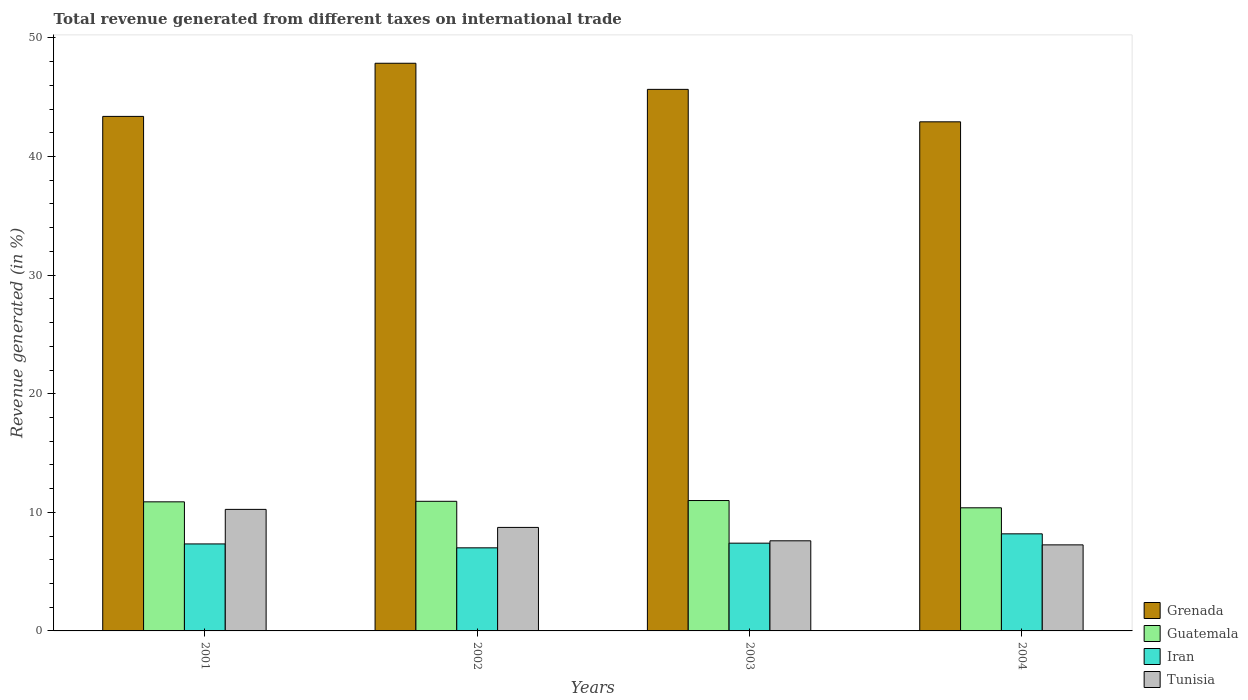How many groups of bars are there?
Offer a very short reply. 4. Are the number of bars per tick equal to the number of legend labels?
Make the answer very short. Yes. What is the total revenue generated in Iran in 2004?
Your answer should be very brief. 8.19. Across all years, what is the maximum total revenue generated in Iran?
Your answer should be very brief. 8.19. Across all years, what is the minimum total revenue generated in Grenada?
Ensure brevity in your answer.  42.93. In which year was the total revenue generated in Tunisia maximum?
Offer a very short reply. 2001. What is the total total revenue generated in Guatemala in the graph?
Provide a succinct answer. 43.19. What is the difference between the total revenue generated in Guatemala in 2002 and that in 2004?
Offer a terse response. 0.55. What is the difference between the total revenue generated in Iran in 2003 and the total revenue generated in Grenada in 2004?
Provide a short and direct response. -35.53. What is the average total revenue generated in Tunisia per year?
Ensure brevity in your answer.  8.46. In the year 2003, what is the difference between the total revenue generated in Iran and total revenue generated in Grenada?
Ensure brevity in your answer.  -38.26. What is the ratio of the total revenue generated in Iran in 2001 to that in 2004?
Offer a very short reply. 0.9. Is the total revenue generated in Guatemala in 2001 less than that in 2002?
Offer a terse response. Yes. What is the difference between the highest and the second highest total revenue generated in Grenada?
Offer a terse response. 2.2. What is the difference between the highest and the lowest total revenue generated in Tunisia?
Offer a terse response. 2.99. What does the 2nd bar from the left in 2004 represents?
Keep it short and to the point. Guatemala. What does the 3rd bar from the right in 2004 represents?
Ensure brevity in your answer.  Guatemala. Is it the case that in every year, the sum of the total revenue generated in Tunisia and total revenue generated in Grenada is greater than the total revenue generated in Guatemala?
Ensure brevity in your answer.  Yes. Are all the bars in the graph horizontal?
Provide a succinct answer. No. What is the difference between two consecutive major ticks on the Y-axis?
Your answer should be compact. 10. Where does the legend appear in the graph?
Offer a terse response. Bottom right. How many legend labels are there?
Your answer should be very brief. 4. What is the title of the graph?
Your response must be concise. Total revenue generated from different taxes on international trade. Does "Guam" appear as one of the legend labels in the graph?
Make the answer very short. No. What is the label or title of the Y-axis?
Your answer should be compact. Revenue generated (in %). What is the Revenue generated (in %) of Grenada in 2001?
Provide a short and direct response. 43.38. What is the Revenue generated (in %) of Guatemala in 2001?
Ensure brevity in your answer.  10.88. What is the Revenue generated (in %) of Iran in 2001?
Your response must be concise. 7.34. What is the Revenue generated (in %) in Tunisia in 2001?
Ensure brevity in your answer.  10.25. What is the Revenue generated (in %) of Grenada in 2002?
Your answer should be very brief. 47.86. What is the Revenue generated (in %) of Guatemala in 2002?
Give a very brief answer. 10.93. What is the Revenue generated (in %) of Iran in 2002?
Keep it short and to the point. 7.01. What is the Revenue generated (in %) of Tunisia in 2002?
Offer a very short reply. 8.73. What is the Revenue generated (in %) of Grenada in 2003?
Provide a short and direct response. 45.66. What is the Revenue generated (in %) of Guatemala in 2003?
Your answer should be compact. 10.99. What is the Revenue generated (in %) in Iran in 2003?
Keep it short and to the point. 7.4. What is the Revenue generated (in %) in Tunisia in 2003?
Your answer should be very brief. 7.6. What is the Revenue generated (in %) of Grenada in 2004?
Provide a succinct answer. 42.93. What is the Revenue generated (in %) in Guatemala in 2004?
Offer a very short reply. 10.38. What is the Revenue generated (in %) of Iran in 2004?
Give a very brief answer. 8.19. What is the Revenue generated (in %) of Tunisia in 2004?
Offer a terse response. 7.26. Across all years, what is the maximum Revenue generated (in %) of Grenada?
Give a very brief answer. 47.86. Across all years, what is the maximum Revenue generated (in %) of Guatemala?
Make the answer very short. 10.99. Across all years, what is the maximum Revenue generated (in %) in Iran?
Make the answer very short. 8.19. Across all years, what is the maximum Revenue generated (in %) in Tunisia?
Keep it short and to the point. 10.25. Across all years, what is the minimum Revenue generated (in %) in Grenada?
Provide a short and direct response. 42.93. Across all years, what is the minimum Revenue generated (in %) of Guatemala?
Provide a succinct answer. 10.38. Across all years, what is the minimum Revenue generated (in %) of Iran?
Give a very brief answer. 7.01. Across all years, what is the minimum Revenue generated (in %) in Tunisia?
Provide a succinct answer. 7.26. What is the total Revenue generated (in %) in Grenada in the graph?
Your response must be concise. 179.84. What is the total Revenue generated (in %) of Guatemala in the graph?
Offer a very short reply. 43.19. What is the total Revenue generated (in %) in Iran in the graph?
Offer a very short reply. 29.93. What is the total Revenue generated (in %) in Tunisia in the graph?
Your response must be concise. 33.83. What is the difference between the Revenue generated (in %) of Grenada in 2001 and that in 2002?
Provide a short and direct response. -4.48. What is the difference between the Revenue generated (in %) in Guatemala in 2001 and that in 2002?
Give a very brief answer. -0.05. What is the difference between the Revenue generated (in %) of Iran in 2001 and that in 2002?
Provide a succinct answer. 0.33. What is the difference between the Revenue generated (in %) of Tunisia in 2001 and that in 2002?
Offer a very short reply. 1.52. What is the difference between the Revenue generated (in %) in Grenada in 2001 and that in 2003?
Offer a terse response. -2.28. What is the difference between the Revenue generated (in %) in Guatemala in 2001 and that in 2003?
Ensure brevity in your answer.  -0.11. What is the difference between the Revenue generated (in %) of Iran in 2001 and that in 2003?
Your answer should be very brief. -0.06. What is the difference between the Revenue generated (in %) of Tunisia in 2001 and that in 2003?
Offer a very short reply. 2.65. What is the difference between the Revenue generated (in %) in Grenada in 2001 and that in 2004?
Offer a terse response. 0.46. What is the difference between the Revenue generated (in %) in Guatemala in 2001 and that in 2004?
Give a very brief answer. 0.5. What is the difference between the Revenue generated (in %) of Iran in 2001 and that in 2004?
Make the answer very short. -0.85. What is the difference between the Revenue generated (in %) in Tunisia in 2001 and that in 2004?
Offer a terse response. 2.99. What is the difference between the Revenue generated (in %) of Grenada in 2002 and that in 2003?
Offer a very short reply. 2.2. What is the difference between the Revenue generated (in %) in Guatemala in 2002 and that in 2003?
Keep it short and to the point. -0.06. What is the difference between the Revenue generated (in %) in Iran in 2002 and that in 2003?
Keep it short and to the point. -0.39. What is the difference between the Revenue generated (in %) in Tunisia in 2002 and that in 2003?
Keep it short and to the point. 1.13. What is the difference between the Revenue generated (in %) in Grenada in 2002 and that in 2004?
Give a very brief answer. 4.94. What is the difference between the Revenue generated (in %) in Guatemala in 2002 and that in 2004?
Give a very brief answer. 0.55. What is the difference between the Revenue generated (in %) of Iran in 2002 and that in 2004?
Your answer should be compact. -1.18. What is the difference between the Revenue generated (in %) of Tunisia in 2002 and that in 2004?
Provide a succinct answer. 1.47. What is the difference between the Revenue generated (in %) in Grenada in 2003 and that in 2004?
Offer a terse response. 2.74. What is the difference between the Revenue generated (in %) of Guatemala in 2003 and that in 2004?
Your answer should be compact. 0.61. What is the difference between the Revenue generated (in %) in Iran in 2003 and that in 2004?
Provide a succinct answer. -0.79. What is the difference between the Revenue generated (in %) in Tunisia in 2003 and that in 2004?
Keep it short and to the point. 0.34. What is the difference between the Revenue generated (in %) in Grenada in 2001 and the Revenue generated (in %) in Guatemala in 2002?
Your response must be concise. 32.45. What is the difference between the Revenue generated (in %) in Grenada in 2001 and the Revenue generated (in %) in Iran in 2002?
Give a very brief answer. 36.38. What is the difference between the Revenue generated (in %) in Grenada in 2001 and the Revenue generated (in %) in Tunisia in 2002?
Keep it short and to the point. 34.66. What is the difference between the Revenue generated (in %) in Guatemala in 2001 and the Revenue generated (in %) in Iran in 2002?
Give a very brief answer. 3.88. What is the difference between the Revenue generated (in %) in Guatemala in 2001 and the Revenue generated (in %) in Tunisia in 2002?
Your answer should be compact. 2.16. What is the difference between the Revenue generated (in %) of Iran in 2001 and the Revenue generated (in %) of Tunisia in 2002?
Provide a succinct answer. -1.39. What is the difference between the Revenue generated (in %) in Grenada in 2001 and the Revenue generated (in %) in Guatemala in 2003?
Make the answer very short. 32.39. What is the difference between the Revenue generated (in %) in Grenada in 2001 and the Revenue generated (in %) in Iran in 2003?
Ensure brevity in your answer.  35.98. What is the difference between the Revenue generated (in %) of Grenada in 2001 and the Revenue generated (in %) of Tunisia in 2003?
Your response must be concise. 35.79. What is the difference between the Revenue generated (in %) of Guatemala in 2001 and the Revenue generated (in %) of Iran in 2003?
Provide a succinct answer. 3.48. What is the difference between the Revenue generated (in %) in Guatemala in 2001 and the Revenue generated (in %) in Tunisia in 2003?
Offer a terse response. 3.29. What is the difference between the Revenue generated (in %) of Iran in 2001 and the Revenue generated (in %) of Tunisia in 2003?
Provide a succinct answer. -0.26. What is the difference between the Revenue generated (in %) of Grenada in 2001 and the Revenue generated (in %) of Guatemala in 2004?
Your answer should be compact. 33. What is the difference between the Revenue generated (in %) in Grenada in 2001 and the Revenue generated (in %) in Iran in 2004?
Your answer should be very brief. 35.2. What is the difference between the Revenue generated (in %) of Grenada in 2001 and the Revenue generated (in %) of Tunisia in 2004?
Keep it short and to the point. 36.13. What is the difference between the Revenue generated (in %) in Guatemala in 2001 and the Revenue generated (in %) in Iran in 2004?
Your answer should be compact. 2.7. What is the difference between the Revenue generated (in %) of Guatemala in 2001 and the Revenue generated (in %) of Tunisia in 2004?
Offer a very short reply. 3.63. What is the difference between the Revenue generated (in %) of Iran in 2001 and the Revenue generated (in %) of Tunisia in 2004?
Your response must be concise. 0.08. What is the difference between the Revenue generated (in %) of Grenada in 2002 and the Revenue generated (in %) of Guatemala in 2003?
Your answer should be compact. 36.87. What is the difference between the Revenue generated (in %) of Grenada in 2002 and the Revenue generated (in %) of Iran in 2003?
Keep it short and to the point. 40.47. What is the difference between the Revenue generated (in %) of Grenada in 2002 and the Revenue generated (in %) of Tunisia in 2003?
Keep it short and to the point. 40.27. What is the difference between the Revenue generated (in %) in Guatemala in 2002 and the Revenue generated (in %) in Iran in 2003?
Ensure brevity in your answer.  3.53. What is the difference between the Revenue generated (in %) of Guatemala in 2002 and the Revenue generated (in %) of Tunisia in 2003?
Your answer should be very brief. 3.33. What is the difference between the Revenue generated (in %) in Iran in 2002 and the Revenue generated (in %) in Tunisia in 2003?
Ensure brevity in your answer.  -0.59. What is the difference between the Revenue generated (in %) in Grenada in 2002 and the Revenue generated (in %) in Guatemala in 2004?
Make the answer very short. 37.48. What is the difference between the Revenue generated (in %) in Grenada in 2002 and the Revenue generated (in %) in Iran in 2004?
Your answer should be very brief. 39.68. What is the difference between the Revenue generated (in %) of Grenada in 2002 and the Revenue generated (in %) of Tunisia in 2004?
Offer a terse response. 40.61. What is the difference between the Revenue generated (in %) in Guatemala in 2002 and the Revenue generated (in %) in Iran in 2004?
Give a very brief answer. 2.74. What is the difference between the Revenue generated (in %) of Guatemala in 2002 and the Revenue generated (in %) of Tunisia in 2004?
Your response must be concise. 3.67. What is the difference between the Revenue generated (in %) in Iran in 2002 and the Revenue generated (in %) in Tunisia in 2004?
Give a very brief answer. -0.25. What is the difference between the Revenue generated (in %) in Grenada in 2003 and the Revenue generated (in %) in Guatemala in 2004?
Your answer should be very brief. 35.28. What is the difference between the Revenue generated (in %) in Grenada in 2003 and the Revenue generated (in %) in Iran in 2004?
Offer a terse response. 37.48. What is the difference between the Revenue generated (in %) of Grenada in 2003 and the Revenue generated (in %) of Tunisia in 2004?
Ensure brevity in your answer.  38.41. What is the difference between the Revenue generated (in %) of Guatemala in 2003 and the Revenue generated (in %) of Iran in 2004?
Provide a succinct answer. 2.81. What is the difference between the Revenue generated (in %) in Guatemala in 2003 and the Revenue generated (in %) in Tunisia in 2004?
Provide a short and direct response. 3.74. What is the difference between the Revenue generated (in %) in Iran in 2003 and the Revenue generated (in %) in Tunisia in 2004?
Ensure brevity in your answer.  0.14. What is the average Revenue generated (in %) of Grenada per year?
Offer a very short reply. 44.96. What is the average Revenue generated (in %) in Guatemala per year?
Give a very brief answer. 10.8. What is the average Revenue generated (in %) in Iran per year?
Make the answer very short. 7.48. What is the average Revenue generated (in %) in Tunisia per year?
Ensure brevity in your answer.  8.46. In the year 2001, what is the difference between the Revenue generated (in %) of Grenada and Revenue generated (in %) of Guatemala?
Provide a succinct answer. 32.5. In the year 2001, what is the difference between the Revenue generated (in %) of Grenada and Revenue generated (in %) of Iran?
Provide a short and direct response. 36.05. In the year 2001, what is the difference between the Revenue generated (in %) in Grenada and Revenue generated (in %) in Tunisia?
Give a very brief answer. 33.14. In the year 2001, what is the difference between the Revenue generated (in %) in Guatemala and Revenue generated (in %) in Iran?
Provide a succinct answer. 3.55. In the year 2001, what is the difference between the Revenue generated (in %) of Guatemala and Revenue generated (in %) of Tunisia?
Provide a short and direct response. 0.64. In the year 2001, what is the difference between the Revenue generated (in %) in Iran and Revenue generated (in %) in Tunisia?
Give a very brief answer. -2.91. In the year 2002, what is the difference between the Revenue generated (in %) of Grenada and Revenue generated (in %) of Guatemala?
Give a very brief answer. 36.94. In the year 2002, what is the difference between the Revenue generated (in %) of Grenada and Revenue generated (in %) of Iran?
Your answer should be compact. 40.86. In the year 2002, what is the difference between the Revenue generated (in %) in Grenada and Revenue generated (in %) in Tunisia?
Keep it short and to the point. 39.14. In the year 2002, what is the difference between the Revenue generated (in %) in Guatemala and Revenue generated (in %) in Iran?
Make the answer very short. 3.92. In the year 2002, what is the difference between the Revenue generated (in %) of Guatemala and Revenue generated (in %) of Tunisia?
Your answer should be very brief. 2.2. In the year 2002, what is the difference between the Revenue generated (in %) of Iran and Revenue generated (in %) of Tunisia?
Your answer should be very brief. -1.72. In the year 2003, what is the difference between the Revenue generated (in %) of Grenada and Revenue generated (in %) of Guatemala?
Offer a terse response. 34.67. In the year 2003, what is the difference between the Revenue generated (in %) of Grenada and Revenue generated (in %) of Iran?
Your response must be concise. 38.26. In the year 2003, what is the difference between the Revenue generated (in %) in Grenada and Revenue generated (in %) in Tunisia?
Ensure brevity in your answer.  38.06. In the year 2003, what is the difference between the Revenue generated (in %) of Guatemala and Revenue generated (in %) of Iran?
Your answer should be very brief. 3.59. In the year 2003, what is the difference between the Revenue generated (in %) of Guatemala and Revenue generated (in %) of Tunisia?
Provide a succinct answer. 3.4. In the year 2003, what is the difference between the Revenue generated (in %) of Iran and Revenue generated (in %) of Tunisia?
Make the answer very short. -0.2. In the year 2004, what is the difference between the Revenue generated (in %) in Grenada and Revenue generated (in %) in Guatemala?
Your answer should be very brief. 32.55. In the year 2004, what is the difference between the Revenue generated (in %) of Grenada and Revenue generated (in %) of Iran?
Your response must be concise. 34.74. In the year 2004, what is the difference between the Revenue generated (in %) in Grenada and Revenue generated (in %) in Tunisia?
Provide a succinct answer. 35.67. In the year 2004, what is the difference between the Revenue generated (in %) of Guatemala and Revenue generated (in %) of Iran?
Offer a terse response. 2.2. In the year 2004, what is the difference between the Revenue generated (in %) in Guatemala and Revenue generated (in %) in Tunisia?
Ensure brevity in your answer.  3.13. In the year 2004, what is the difference between the Revenue generated (in %) in Iran and Revenue generated (in %) in Tunisia?
Make the answer very short. 0.93. What is the ratio of the Revenue generated (in %) in Grenada in 2001 to that in 2002?
Your answer should be compact. 0.91. What is the ratio of the Revenue generated (in %) in Guatemala in 2001 to that in 2002?
Your answer should be compact. 1. What is the ratio of the Revenue generated (in %) of Iran in 2001 to that in 2002?
Provide a succinct answer. 1.05. What is the ratio of the Revenue generated (in %) of Tunisia in 2001 to that in 2002?
Your answer should be very brief. 1.17. What is the ratio of the Revenue generated (in %) of Grenada in 2001 to that in 2003?
Offer a terse response. 0.95. What is the ratio of the Revenue generated (in %) of Tunisia in 2001 to that in 2003?
Keep it short and to the point. 1.35. What is the ratio of the Revenue generated (in %) in Grenada in 2001 to that in 2004?
Provide a succinct answer. 1.01. What is the ratio of the Revenue generated (in %) of Guatemala in 2001 to that in 2004?
Provide a short and direct response. 1.05. What is the ratio of the Revenue generated (in %) in Iran in 2001 to that in 2004?
Your response must be concise. 0.9. What is the ratio of the Revenue generated (in %) of Tunisia in 2001 to that in 2004?
Give a very brief answer. 1.41. What is the ratio of the Revenue generated (in %) of Grenada in 2002 to that in 2003?
Offer a very short reply. 1.05. What is the ratio of the Revenue generated (in %) of Guatemala in 2002 to that in 2003?
Your response must be concise. 0.99. What is the ratio of the Revenue generated (in %) in Iran in 2002 to that in 2003?
Your answer should be very brief. 0.95. What is the ratio of the Revenue generated (in %) in Tunisia in 2002 to that in 2003?
Provide a short and direct response. 1.15. What is the ratio of the Revenue generated (in %) of Grenada in 2002 to that in 2004?
Your response must be concise. 1.11. What is the ratio of the Revenue generated (in %) in Guatemala in 2002 to that in 2004?
Your answer should be very brief. 1.05. What is the ratio of the Revenue generated (in %) in Iran in 2002 to that in 2004?
Give a very brief answer. 0.86. What is the ratio of the Revenue generated (in %) in Tunisia in 2002 to that in 2004?
Ensure brevity in your answer.  1.2. What is the ratio of the Revenue generated (in %) in Grenada in 2003 to that in 2004?
Ensure brevity in your answer.  1.06. What is the ratio of the Revenue generated (in %) in Guatemala in 2003 to that in 2004?
Your response must be concise. 1.06. What is the ratio of the Revenue generated (in %) in Iran in 2003 to that in 2004?
Provide a short and direct response. 0.9. What is the ratio of the Revenue generated (in %) in Tunisia in 2003 to that in 2004?
Provide a succinct answer. 1.05. What is the difference between the highest and the second highest Revenue generated (in %) of Grenada?
Give a very brief answer. 2.2. What is the difference between the highest and the second highest Revenue generated (in %) of Guatemala?
Provide a short and direct response. 0.06. What is the difference between the highest and the second highest Revenue generated (in %) of Iran?
Your answer should be very brief. 0.79. What is the difference between the highest and the second highest Revenue generated (in %) in Tunisia?
Your answer should be very brief. 1.52. What is the difference between the highest and the lowest Revenue generated (in %) of Grenada?
Provide a succinct answer. 4.94. What is the difference between the highest and the lowest Revenue generated (in %) in Guatemala?
Provide a succinct answer. 0.61. What is the difference between the highest and the lowest Revenue generated (in %) in Iran?
Give a very brief answer. 1.18. What is the difference between the highest and the lowest Revenue generated (in %) in Tunisia?
Keep it short and to the point. 2.99. 